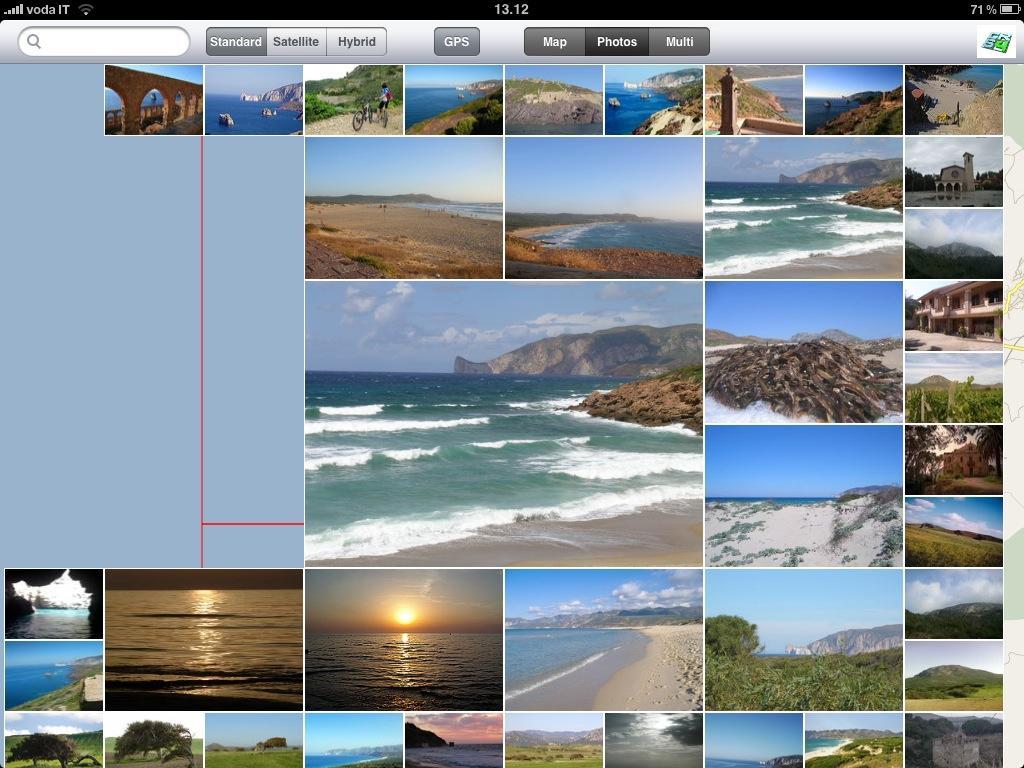Can you describe this image briefly? In the picture I can see the screen of a computer. On the screen I can see the collage images. I can see the images of a bridge construction, beach view of the oceans, sunrise, trees and a house construction. 